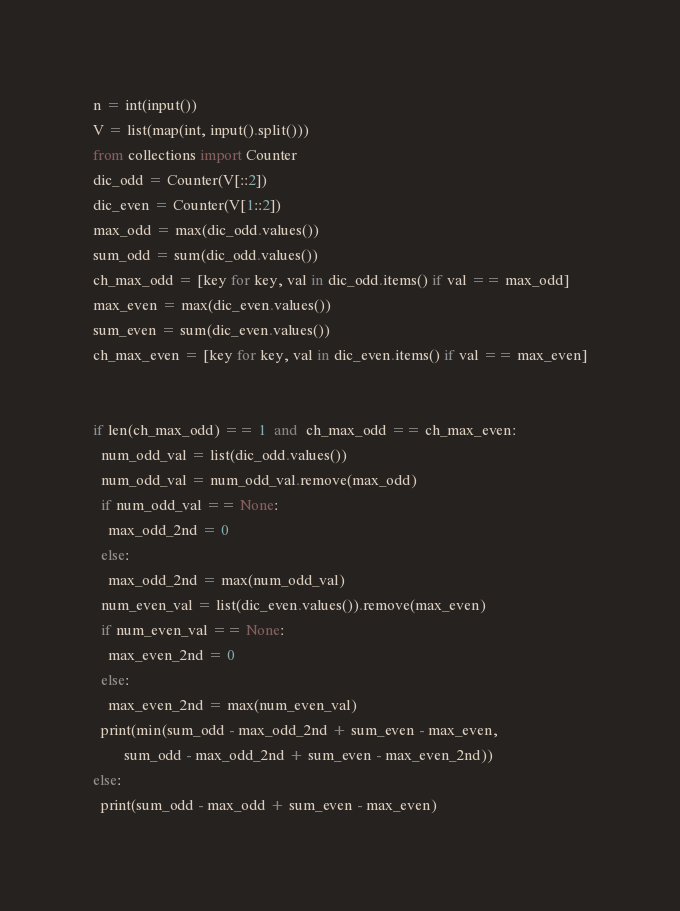<code> <loc_0><loc_0><loc_500><loc_500><_Python_>n = int(input())
V = list(map(int, input().split()))
from collections import Counter
dic_odd = Counter(V[::2])
dic_even = Counter(V[1::2])
max_odd = max(dic_odd.values())
sum_odd = sum(dic_odd.values())
ch_max_odd = [key for key, val in dic_odd.items() if val == max_odd]
max_even = max(dic_even.values())
sum_even = sum(dic_even.values())
ch_max_even = [key for key, val in dic_even.items() if val == max_even]


if len(ch_max_odd) == 1  and  ch_max_odd == ch_max_even:
  num_odd_val = list(dic_odd.values())
  num_odd_val = num_odd_val.remove(max_odd)
  if num_odd_val == None:
    max_odd_2nd = 0
  else:
    max_odd_2nd = max(num_odd_val)
  num_even_val = list(dic_even.values()).remove(max_even)
  if num_even_val == None:
    max_even_2nd = 0
  else:
    max_even_2nd = max(num_even_val)  
  print(min(sum_odd - max_odd_2nd + sum_even - max_even,
        sum_odd - max_odd_2nd + sum_even - max_even_2nd))
else:
  print(sum_odd - max_odd + sum_even - max_even)
</code> 